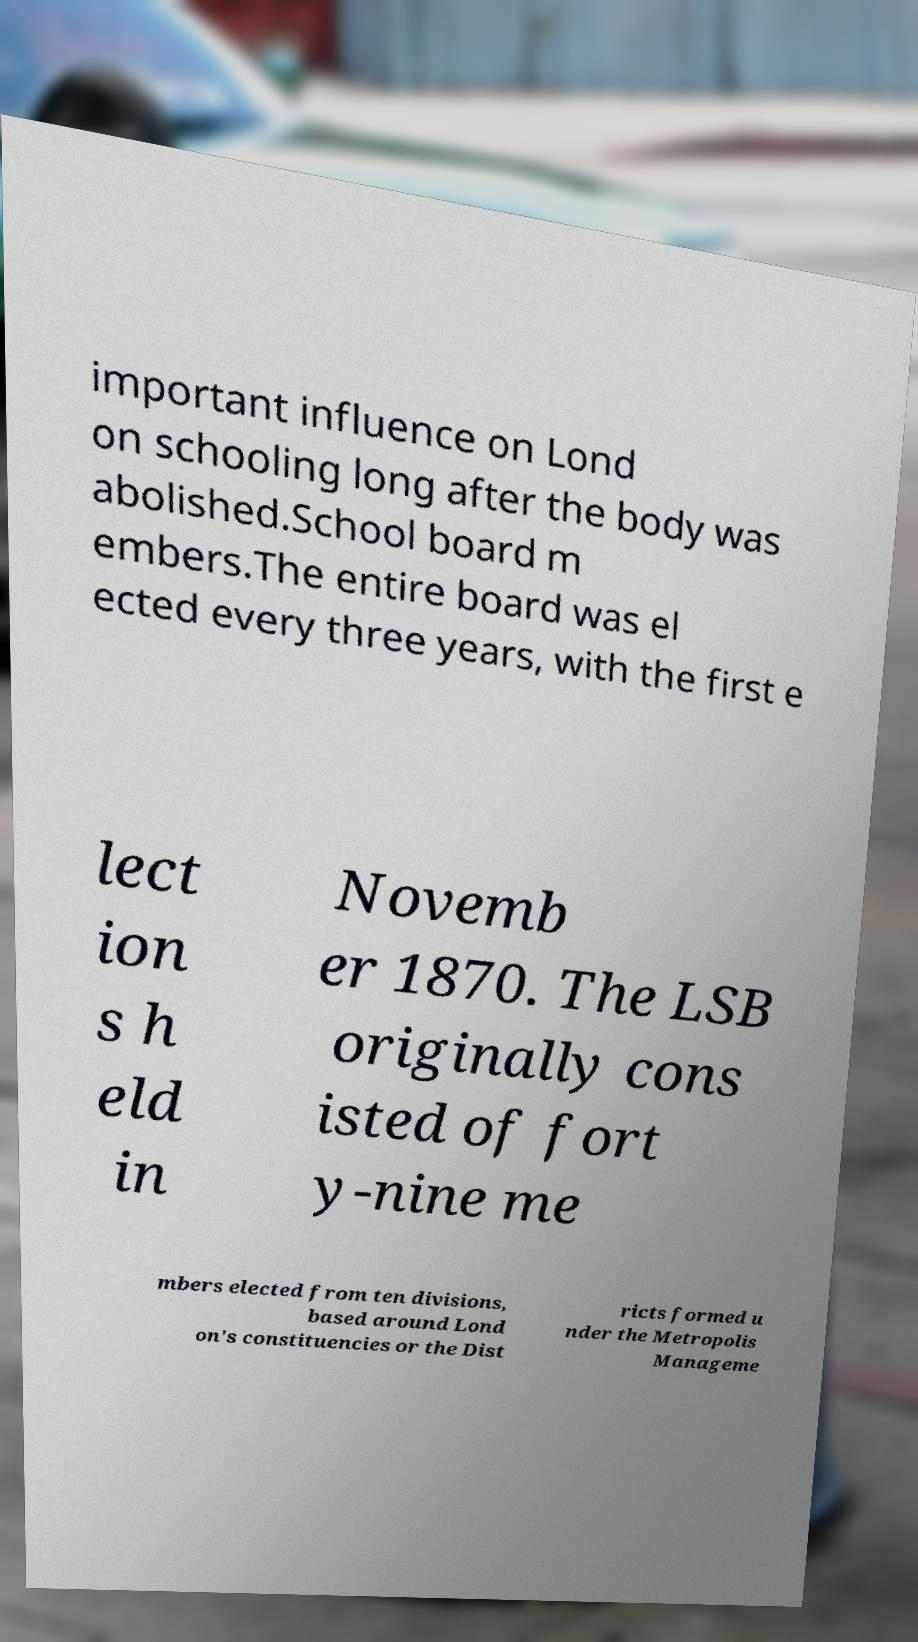There's text embedded in this image that I need extracted. Can you transcribe it verbatim? important influence on Lond on schooling long after the body was abolished.School board m embers.The entire board was el ected every three years, with the first e lect ion s h eld in Novemb er 1870. The LSB originally cons isted of fort y-nine me mbers elected from ten divisions, based around Lond on's constituencies or the Dist ricts formed u nder the Metropolis Manageme 